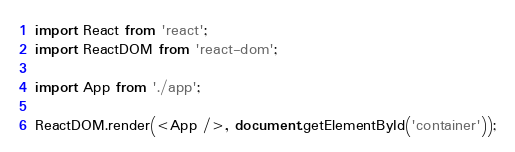Convert code to text. <code><loc_0><loc_0><loc_500><loc_500><_JavaScript_>import React from 'react';
import ReactDOM from 'react-dom';

import App from './app';

ReactDOM.render(<App />, document.getElementById('container'));
</code> 